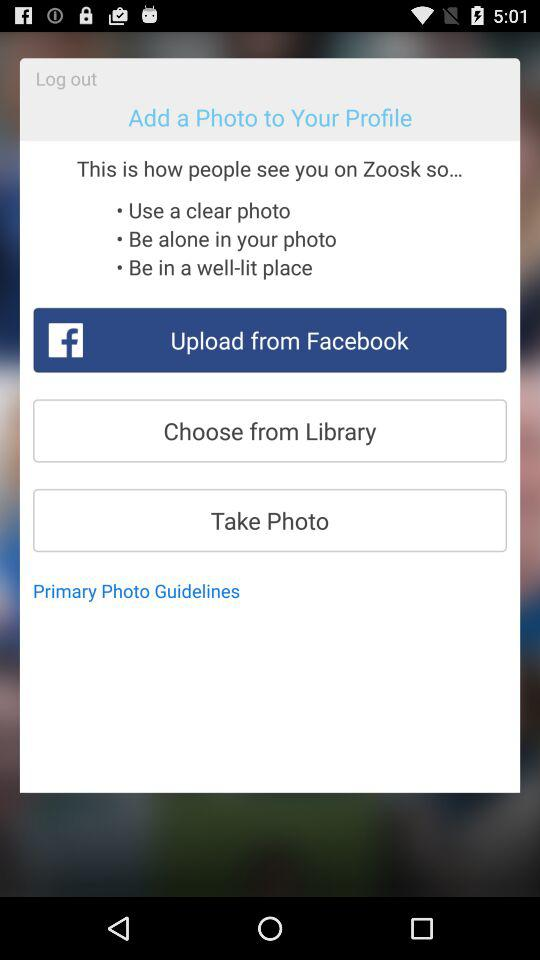What are the options for adding profile photos? The options are "Upload from Facebook", "Choose from Library" and "Take Photo". 